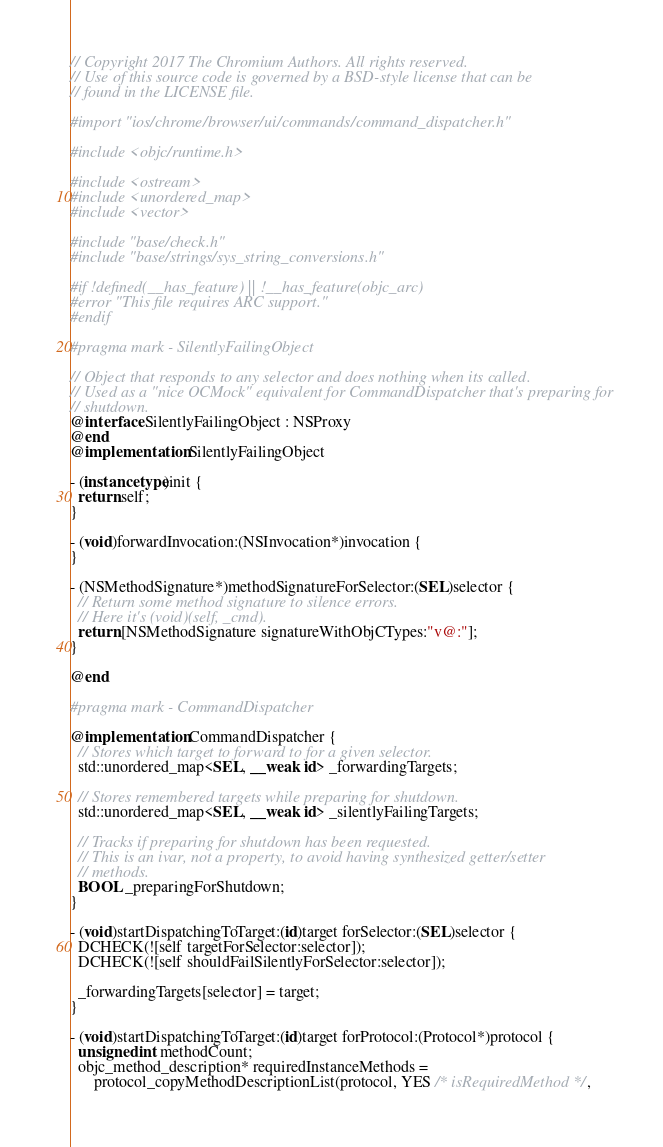Convert code to text. <code><loc_0><loc_0><loc_500><loc_500><_ObjectiveC_>// Copyright 2017 The Chromium Authors. All rights reserved.
// Use of this source code is governed by a BSD-style license that can be
// found in the LICENSE file.

#import "ios/chrome/browser/ui/commands/command_dispatcher.h"

#include <objc/runtime.h>

#include <ostream>
#include <unordered_map>
#include <vector>

#include "base/check.h"
#include "base/strings/sys_string_conversions.h"

#if !defined(__has_feature) || !__has_feature(objc_arc)
#error "This file requires ARC support."
#endif

#pragma mark - SilentlyFailingObject

// Object that responds to any selector and does nothing when its called.
// Used as a "nice OCMock" equivalent for CommandDispatcher that's preparing for
// shutdown.
@interface SilentlyFailingObject : NSProxy
@end
@implementation SilentlyFailingObject

- (instancetype)init {
  return self;
}

- (void)forwardInvocation:(NSInvocation*)invocation {
}

- (NSMethodSignature*)methodSignatureForSelector:(SEL)selector {
  // Return some method signature to silence errors.
  // Here it's (void)(self, _cmd).
  return [NSMethodSignature signatureWithObjCTypes:"v@:"];
}

@end

#pragma mark - CommandDispatcher

@implementation CommandDispatcher {
  // Stores which target to forward to for a given selector.
  std::unordered_map<SEL, __weak id> _forwardingTargets;

  // Stores remembered targets while preparing for shutdown.
  std::unordered_map<SEL, __weak id> _silentlyFailingTargets;

  // Tracks if preparing for shutdown has been requested.
  // This is an ivar, not a property, to avoid having synthesized getter/setter
  // methods.
  BOOL _preparingForShutdown;
}

- (void)startDispatchingToTarget:(id)target forSelector:(SEL)selector {
  DCHECK(![self targetForSelector:selector]);
  DCHECK(![self shouldFailSilentlyForSelector:selector]);

  _forwardingTargets[selector] = target;
}

- (void)startDispatchingToTarget:(id)target forProtocol:(Protocol*)protocol {
  unsigned int methodCount;
  objc_method_description* requiredInstanceMethods =
      protocol_copyMethodDescriptionList(protocol, YES /* isRequiredMethod */,</code> 